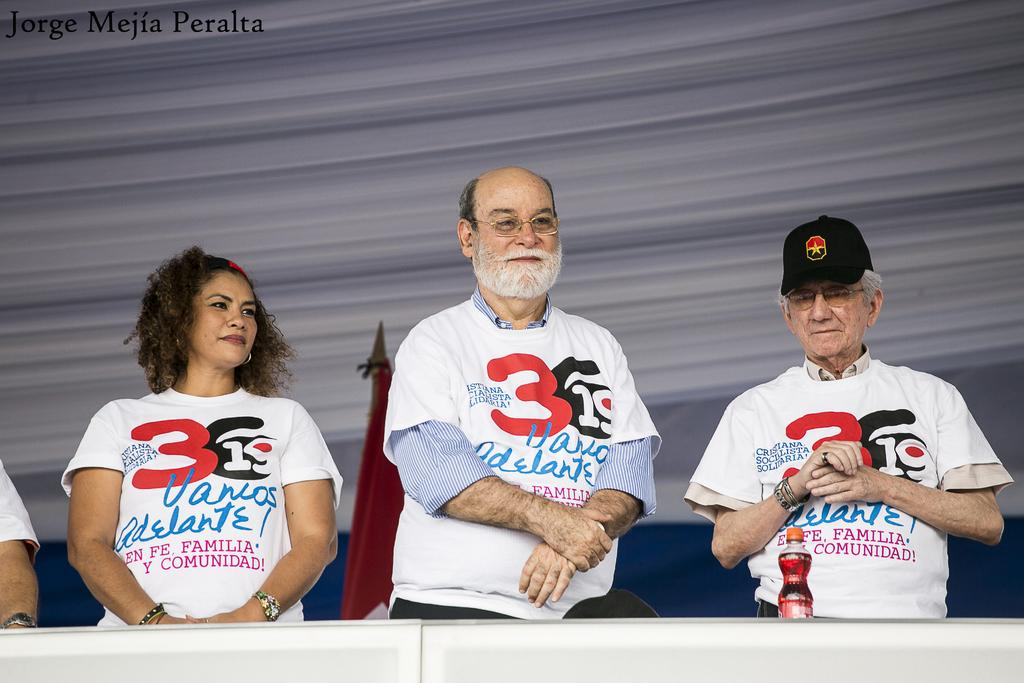<image>
Write a terse but informative summary of the picture. Three people with the number 3 in rd on their t-shirts stand together. 